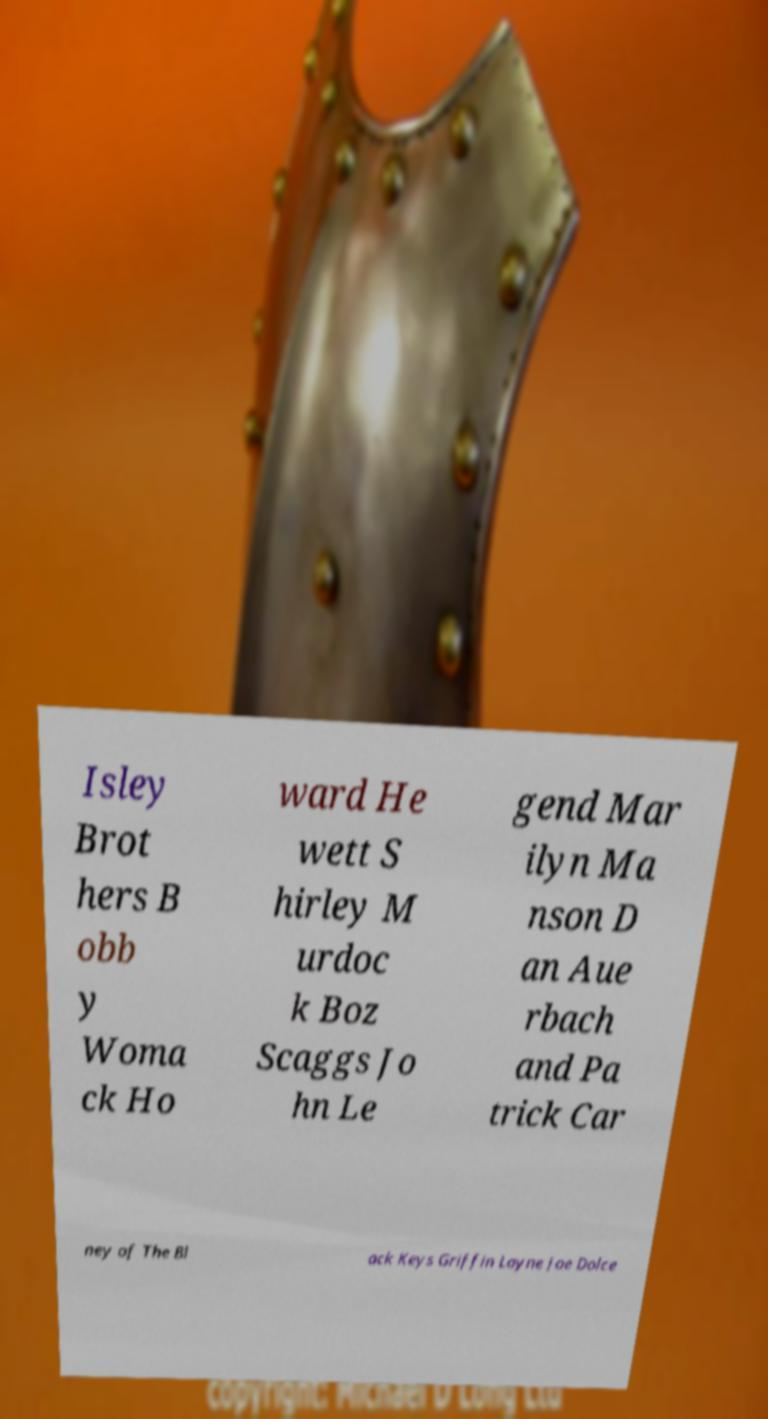Could you extract and type out the text from this image? Isley Brot hers B obb y Woma ck Ho ward He wett S hirley M urdoc k Boz Scaggs Jo hn Le gend Mar ilyn Ma nson D an Aue rbach and Pa trick Car ney of The Bl ack Keys Griffin Layne Joe Dolce 